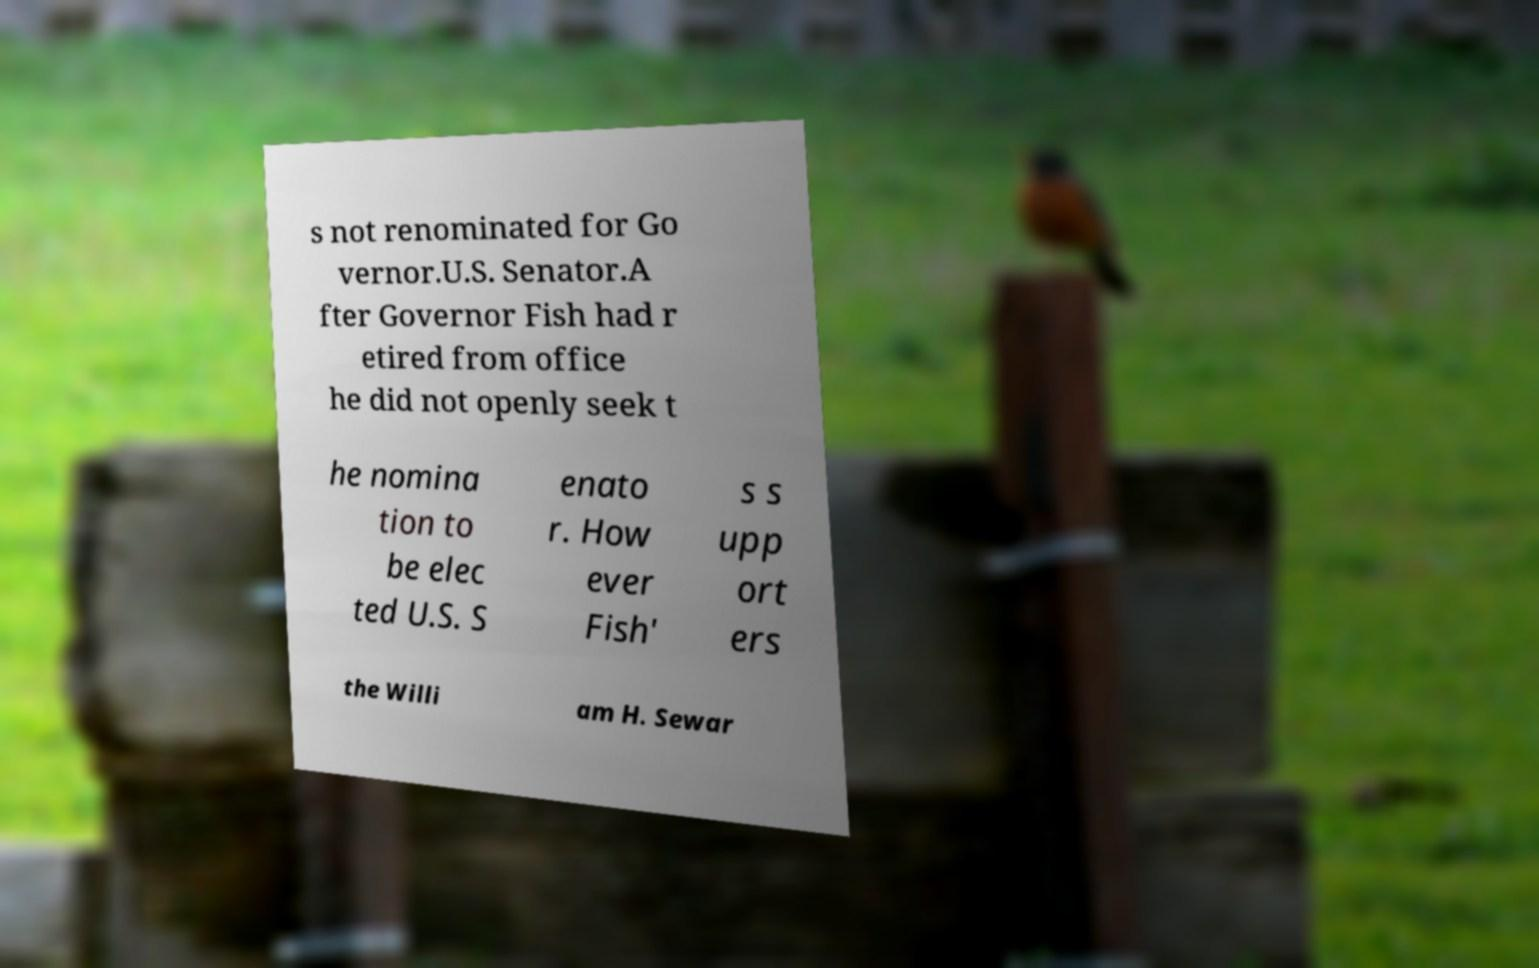Please read and relay the text visible in this image. What does it say? s not renominated for Go vernor.U.S. Senator.A fter Governor Fish had r etired from office he did not openly seek t he nomina tion to be elec ted U.S. S enato r. How ever Fish' s s upp ort ers the Willi am H. Sewar 